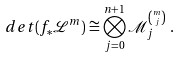<formula> <loc_0><loc_0><loc_500><loc_500>& d e t ( f _ { * } \mathcal { L } ^ { m } ) \cong \bigotimes _ { j = 0 } ^ { n + 1 } \mathcal { M } _ { j } ^ { \binom { m } { j } } \ .</formula> 